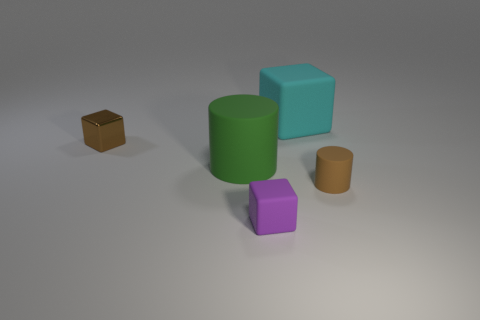Add 1 small matte blocks. How many objects exist? 6 Subtract all cylinders. How many objects are left? 3 Subtract 0 gray cylinders. How many objects are left? 5 Subtract all green cylinders. Subtract all purple things. How many objects are left? 3 Add 3 tiny brown cylinders. How many tiny brown cylinders are left? 4 Add 3 big red objects. How many big red objects exist? 3 